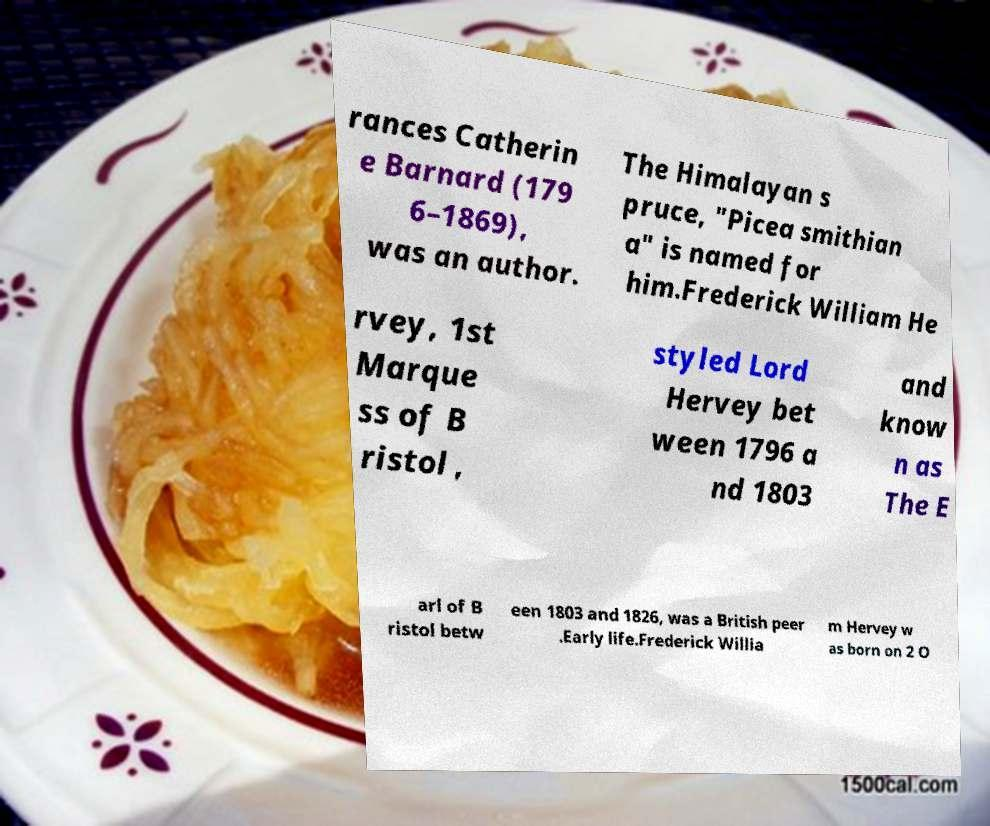Please identify and transcribe the text found in this image. rances Catherin e Barnard (179 6–1869), was an author. The Himalayan s pruce, "Picea smithian a" is named for him.Frederick William He rvey, 1st Marque ss of B ristol , styled Lord Hervey bet ween 1796 a nd 1803 and know n as The E arl of B ristol betw een 1803 and 1826, was a British peer .Early life.Frederick Willia m Hervey w as born on 2 O 